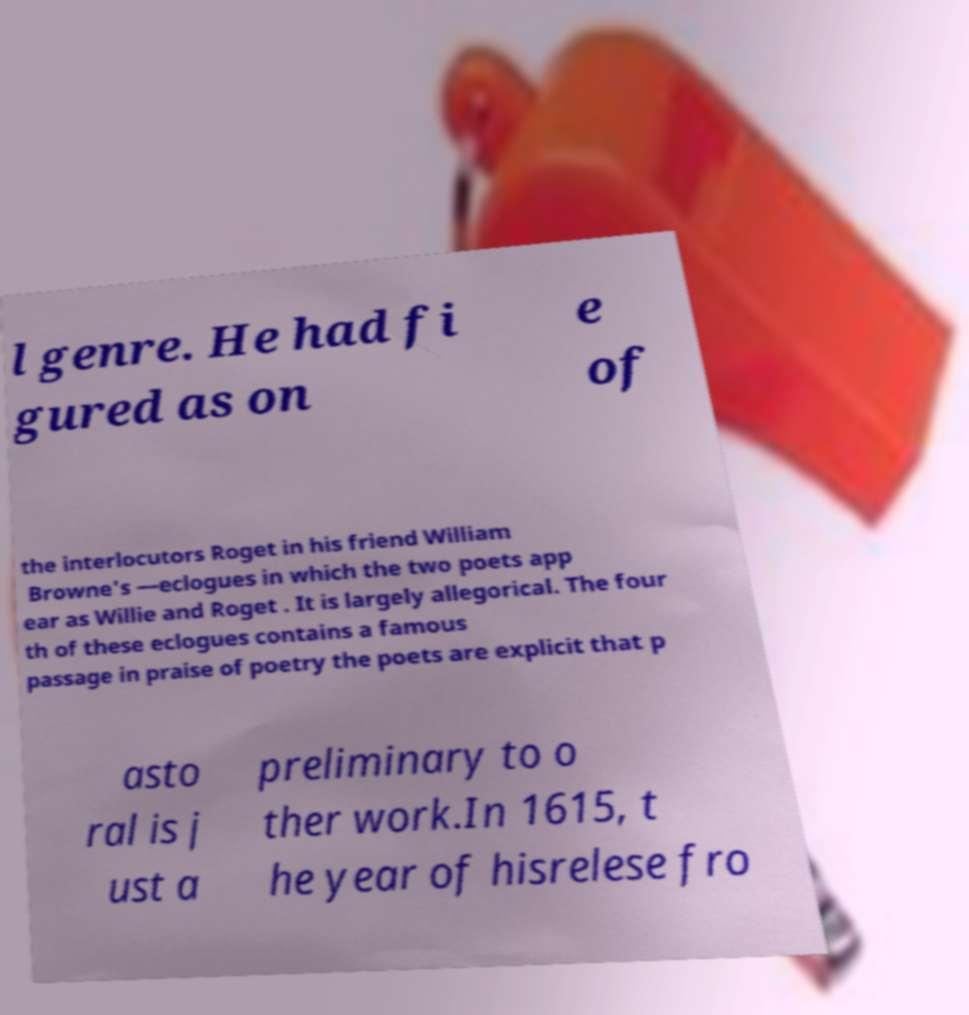Can you read and provide the text displayed in the image?This photo seems to have some interesting text. Can you extract and type it out for me? l genre. He had fi gured as on e of the interlocutors Roget in his friend William Browne's —eclogues in which the two poets app ear as Willie and Roget . It is largely allegorical. The four th of these eclogues contains a famous passage in praise of poetry the poets are explicit that p asto ral is j ust a preliminary to o ther work.In 1615, t he year of hisrelese fro 